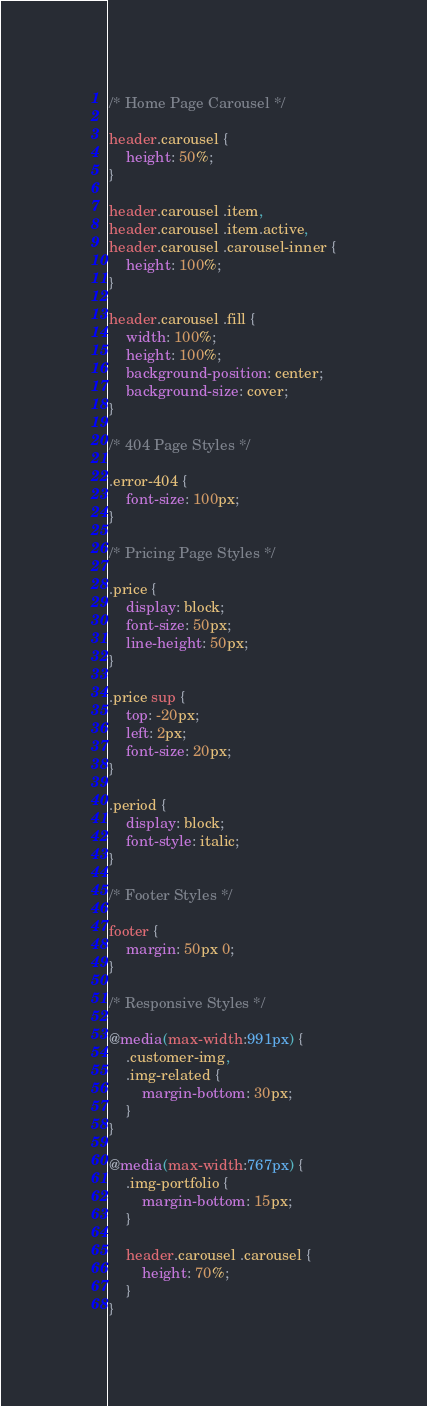<code> <loc_0><loc_0><loc_500><loc_500><_CSS_>
/* Home Page Carousel */

header.carousel {
    height: 50%;
}

header.carousel .item,
header.carousel .item.active,
header.carousel .carousel-inner {
    height: 100%;
}

header.carousel .fill {
    width: 100%;
    height: 100%;
    background-position: center;
    background-size: cover;
}

/* 404 Page Styles */

.error-404 {
    font-size: 100px;
}

/* Pricing Page Styles */

.price {
    display: block;
    font-size: 50px;
    line-height: 50px;
}

.price sup {
    top: -20px;
    left: 2px;
    font-size: 20px;
}

.period {
    display: block;
    font-style: italic;
}

/* Footer Styles */

footer {
    margin: 50px 0;
}

/* Responsive Styles */

@media(max-width:991px) {
    .customer-img,
    .img-related {
        margin-bottom: 30px;
    }
}

@media(max-width:767px) {
    .img-portfolio {
        margin-bottom: 15px;
    }

    header.carousel .carousel {
        height: 70%;
    }
}
</code> 